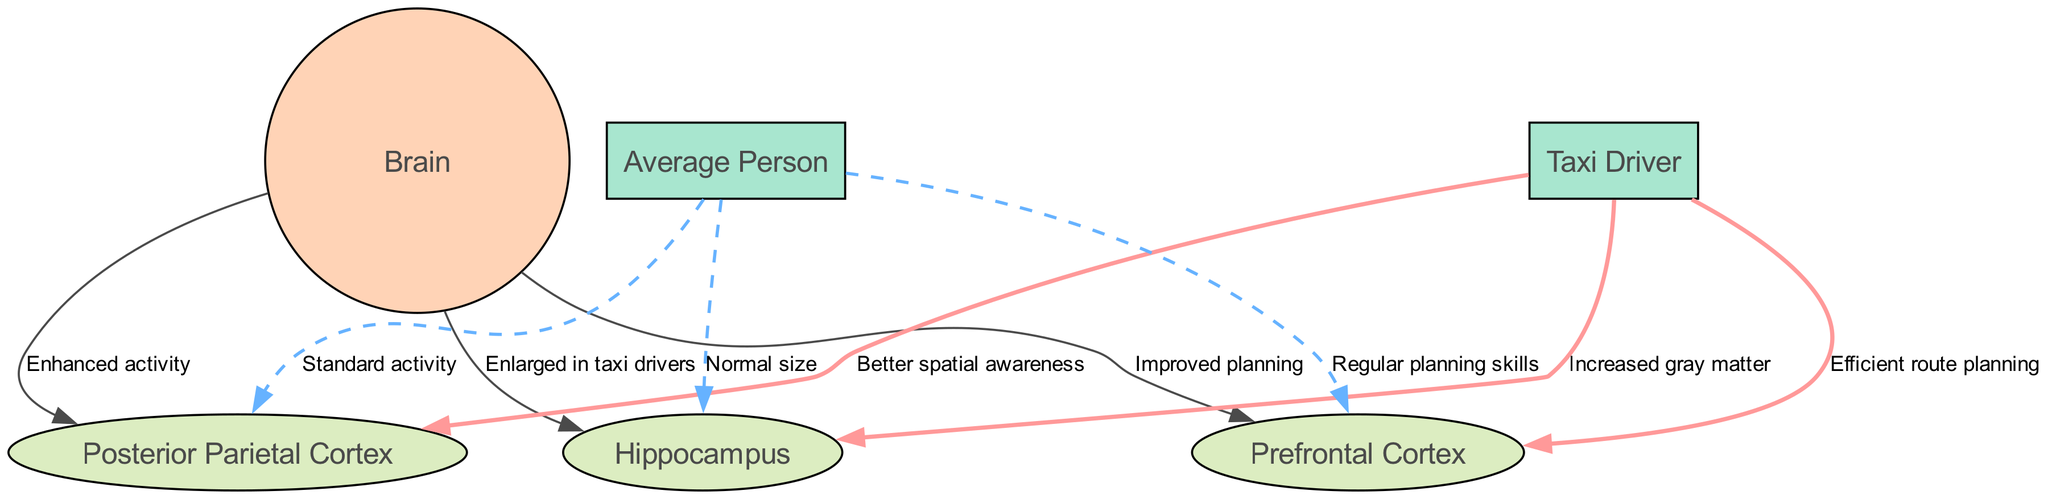What part of the brain is enlarged in taxi drivers? The diagram indicates that the hippocampus is labeled as "Enlarged in taxi drivers" connected to the brain node, showing that this specific area experiences noticeable growth due to the experiences of taxi drivers.
Answer: Hippocampus How many edges connect to the brain node? By examining the diagram, we can see that there are three distinct edges leading from the brain node to the hippocampus, posterior parietal cortex, and prefrontal cortex. This means three areas are connected to the brain in the context presented.
Answer: 3 What is improved in the prefrontal cortex of taxi drivers? The edge from the taxi driver to the prefrontal cortex is labeled "Efficient route planning." This implies that taxi drivers experience enhancements in their ability to plan routes within this brain area.
Answer: Efficient route planning Which brain area shows enhanced activity? According to the diagram, the label on the edge connecting the brain to the posterior parietal cortex states "Enhanced activity," indicating that this particular area exhibits increased function beyond what is typical.
Answer: Posterior Parietal Cortex What is the difference in gray matter between taxi drivers and the average person? The diagram shows an edge from the taxi driver to the hippocampus marked "Increased gray matter," and another edge from the average person to the same node stating "Normal size," which demonstrates a contrast in gray matter between these two groups.
Answer: Increased gray matter 